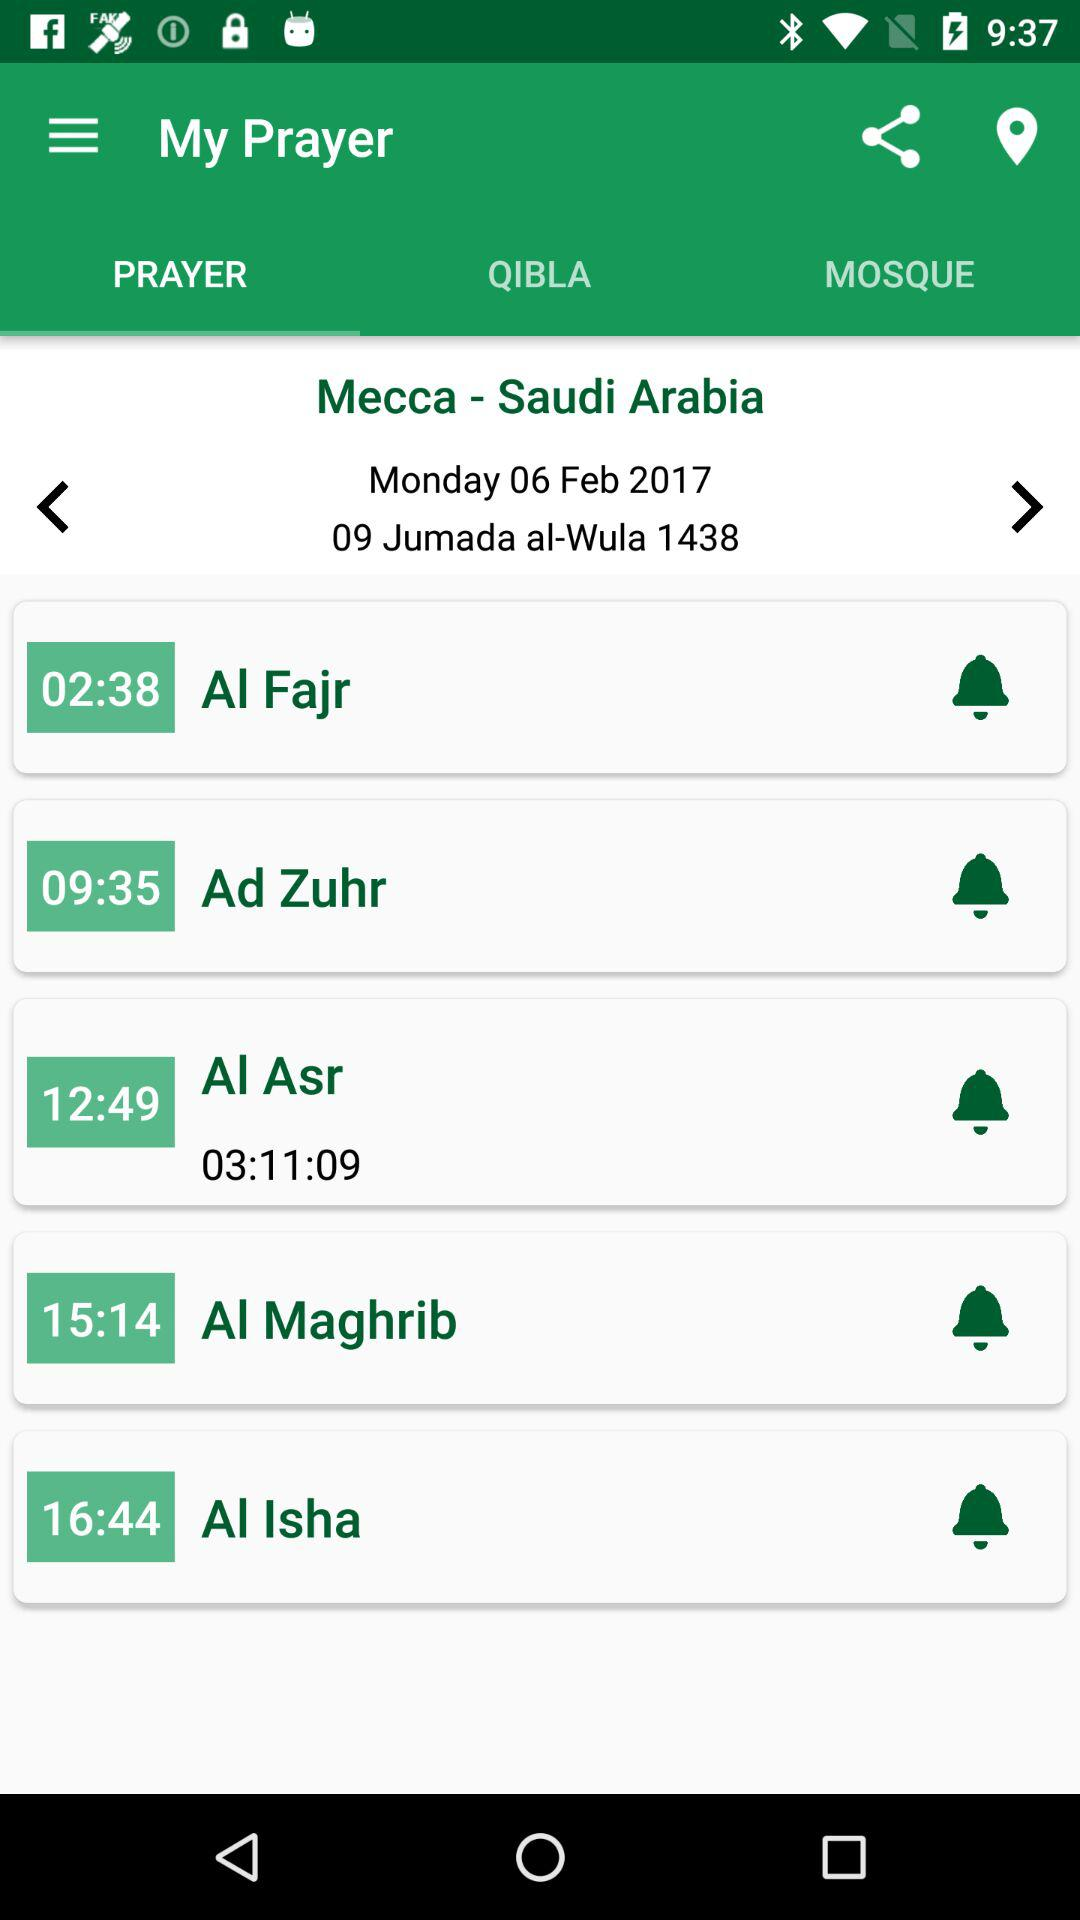What is the time duration of the prayer "Al Asr"? The time duration of the prayer "Al Asr" is 3 hours 11 minutes 9 seconds. 